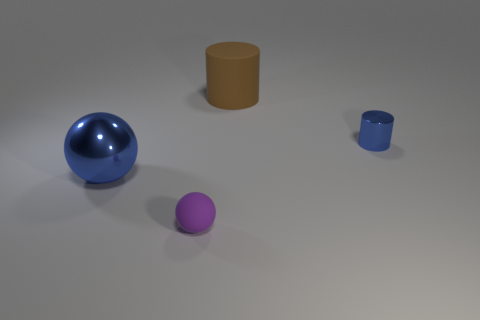Are there more matte cylinders on the left side of the small matte sphere than purple things that are behind the large sphere? no 